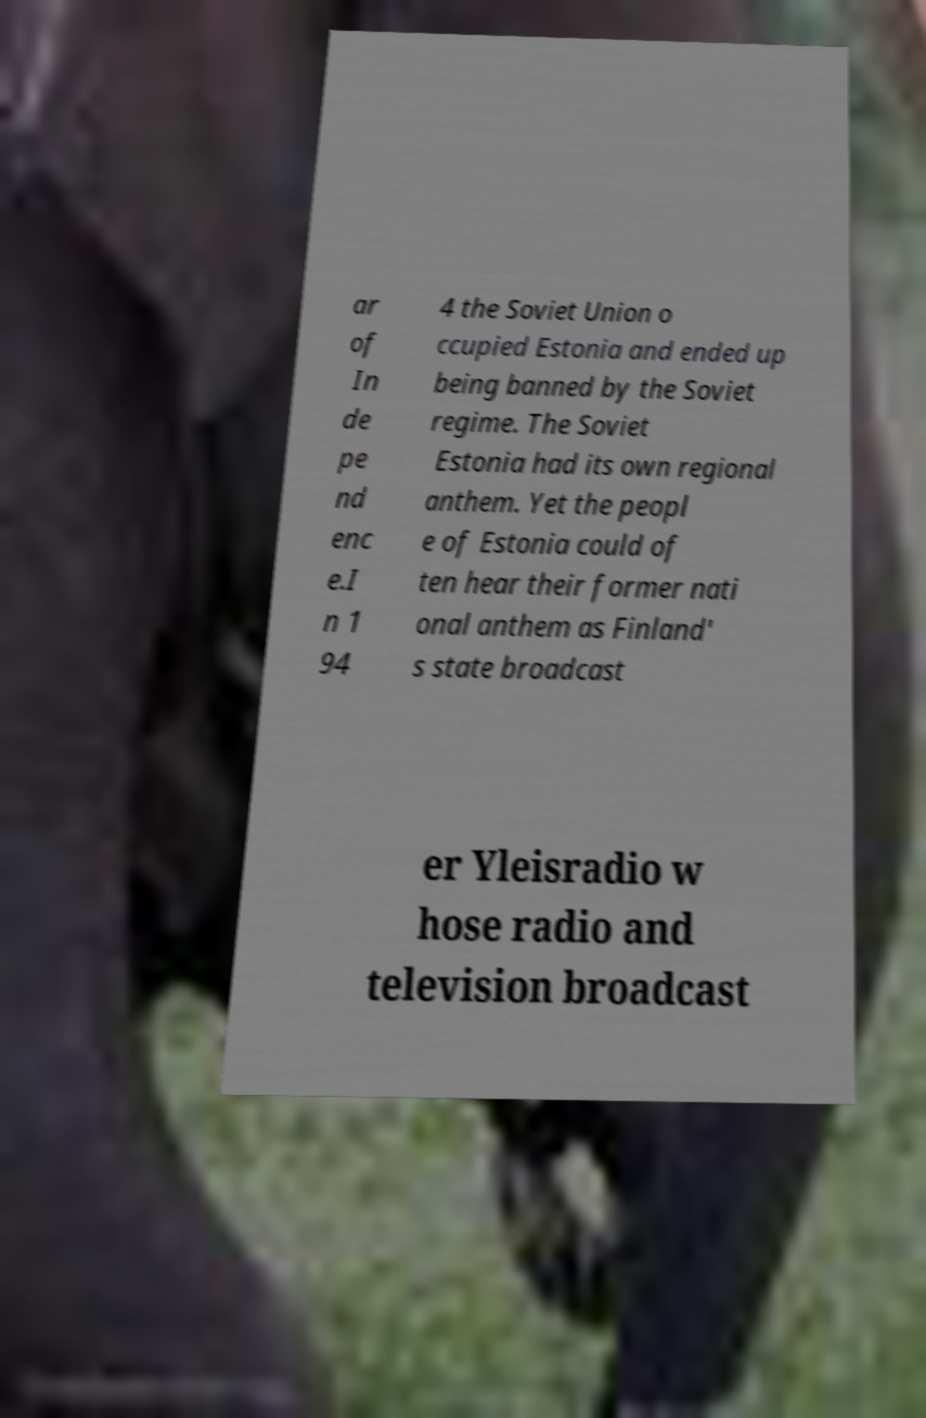Can you accurately transcribe the text from the provided image for me? ar of In de pe nd enc e.I n 1 94 4 the Soviet Union o ccupied Estonia and ended up being banned by the Soviet regime. The Soviet Estonia had its own regional anthem. Yet the peopl e of Estonia could of ten hear their former nati onal anthem as Finland' s state broadcast er Yleisradio w hose radio and television broadcast 